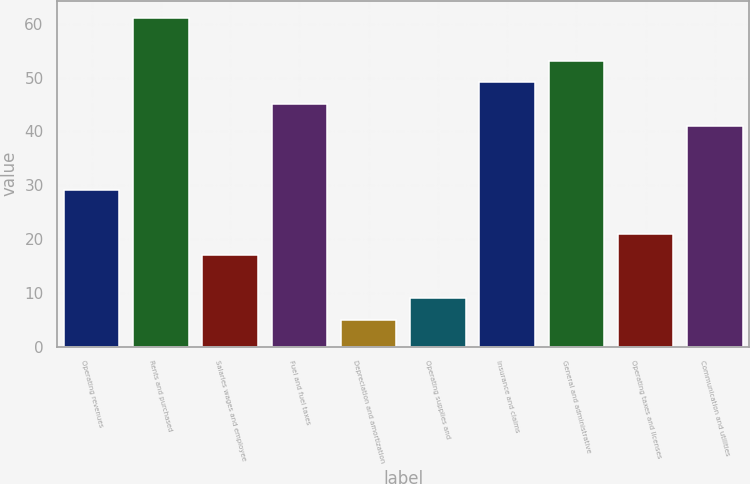Convert chart to OTSL. <chart><loc_0><loc_0><loc_500><loc_500><bar_chart><fcel>Operating revenues<fcel>Rents and purchased<fcel>Salaries wages and employee<fcel>Fuel and fuel taxes<fcel>Depreciation and amortization<fcel>Operating supplies and<fcel>Insurance and claims<fcel>General and administrative<fcel>Operating taxes and licenses<fcel>Communication and utilities<nl><fcel>29.04<fcel>61.2<fcel>16.98<fcel>45.12<fcel>4.92<fcel>8.94<fcel>49.14<fcel>53.16<fcel>21<fcel>41.1<nl></chart> 